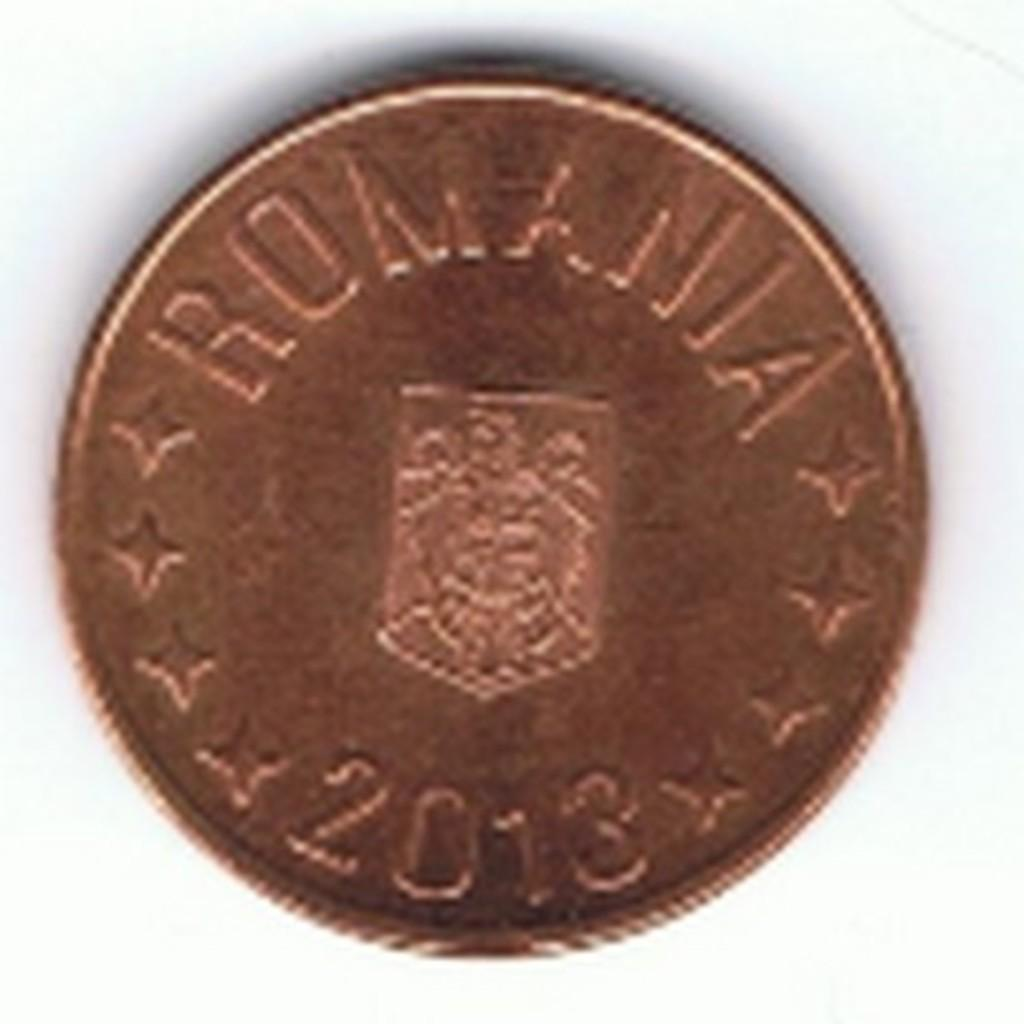Provide a one-sentence caption for the provided image. A slightly blurred picture of a 2013 Romanian coin. 